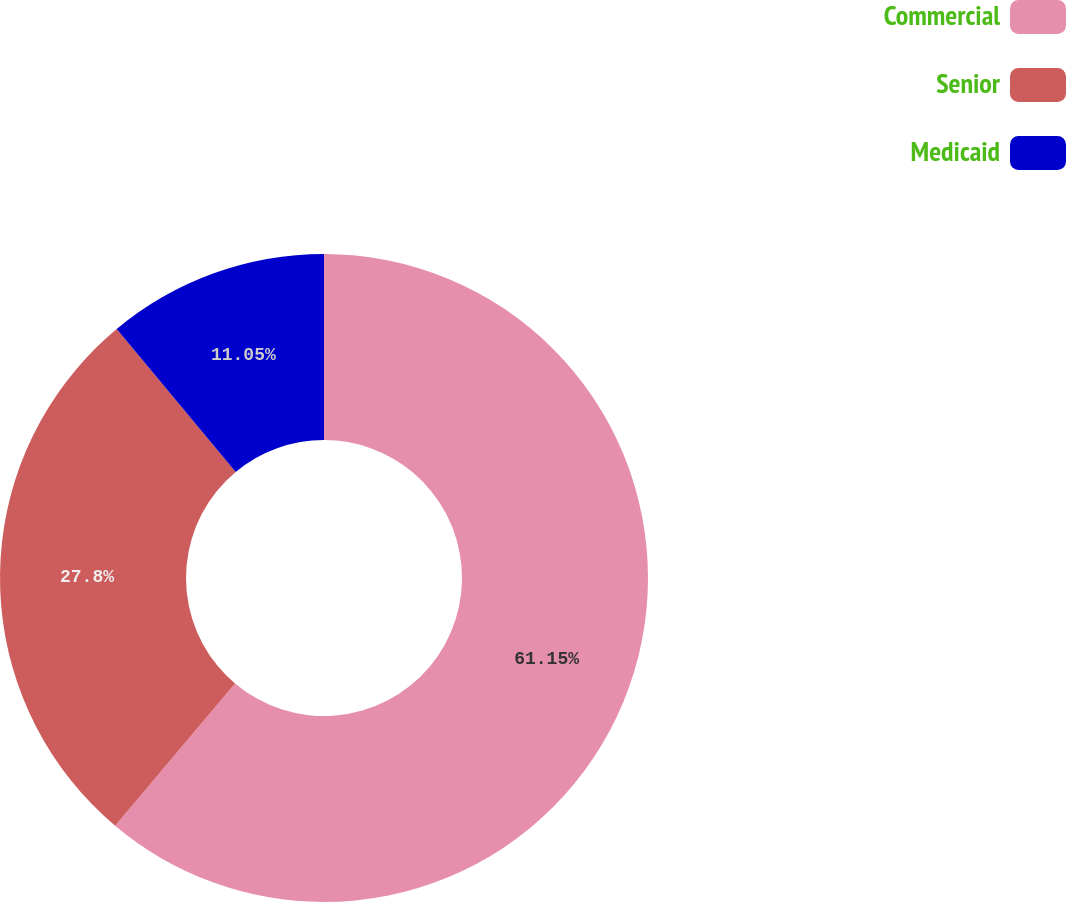<chart> <loc_0><loc_0><loc_500><loc_500><pie_chart><fcel>Commercial<fcel>Senior<fcel>Medicaid<nl><fcel>61.15%<fcel>27.8%<fcel>11.05%<nl></chart> 